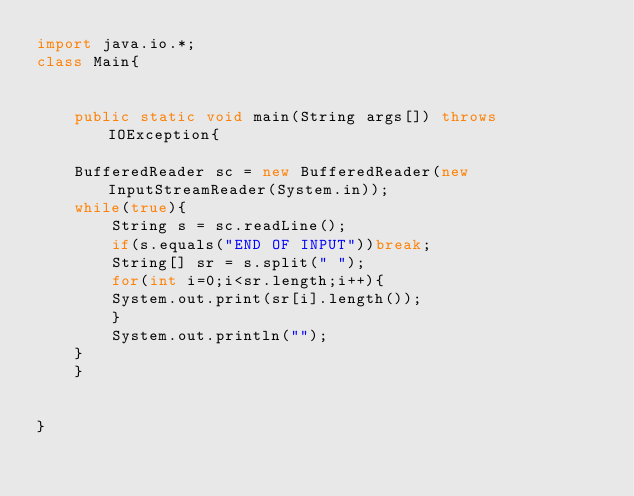<code> <loc_0><loc_0><loc_500><loc_500><_Java_>import java.io.*;
class Main{


    public static void main(String args[]) throws IOException{

	BufferedReader sc = new BufferedReader(new InputStreamReader(System.in));
	while(true){
	    String s = sc.readLine();
	    if(s.equals("END OF INPUT"))break;
	    String[] sr = s.split(" ");
	    for(int i=0;i<sr.length;i++){
		System.out.print(sr[i].length());
	    }
	    System.out.println("");
	}
    }


}</code> 